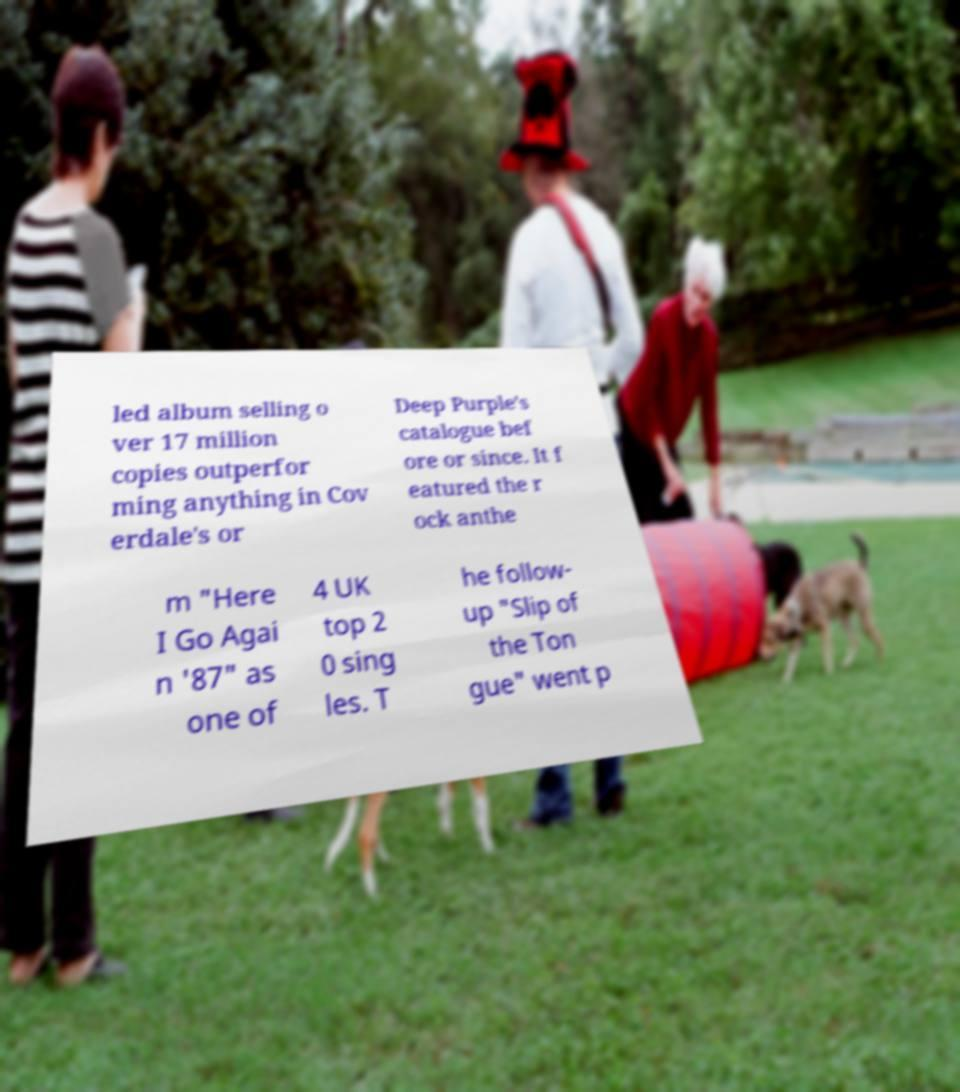There's text embedded in this image that I need extracted. Can you transcribe it verbatim? led album selling o ver 17 million copies outperfor ming anything in Cov erdale's or Deep Purple's catalogue bef ore or since. It f eatured the r ock anthe m "Here I Go Agai n '87" as one of 4 UK top 2 0 sing les. T he follow- up "Slip of the Ton gue" went p 